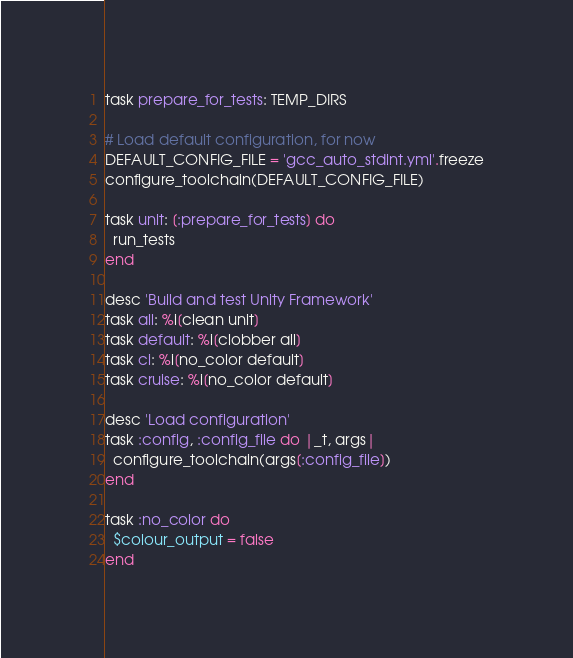<code> <loc_0><loc_0><loc_500><loc_500><_Ruby_>task prepare_for_tests: TEMP_DIRS

# Load default configuration, for now
DEFAULT_CONFIG_FILE = 'gcc_auto_stdint.yml'.freeze
configure_toolchain(DEFAULT_CONFIG_FILE)

task unit: [:prepare_for_tests] do
  run_tests
end

desc 'Build and test Unity Framework'
task all: %i[clean unit]
task default: %i[clobber all]
task ci: %i[no_color default]
task cruise: %i[no_color default]

desc 'Load configuration'
task :config, :config_file do |_t, args|
  configure_toolchain(args[:config_file])
end

task :no_color do
  $colour_output = false
end
</code> 